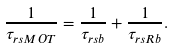Convert formula to latex. <formula><loc_0><loc_0><loc_500><loc_500>\frac { 1 } { \tau _ { r s { M O T } } } = \frac { 1 } { \tau _ { r s { b } } } + \frac { 1 } { \tau _ { r s { R b } } } .</formula> 